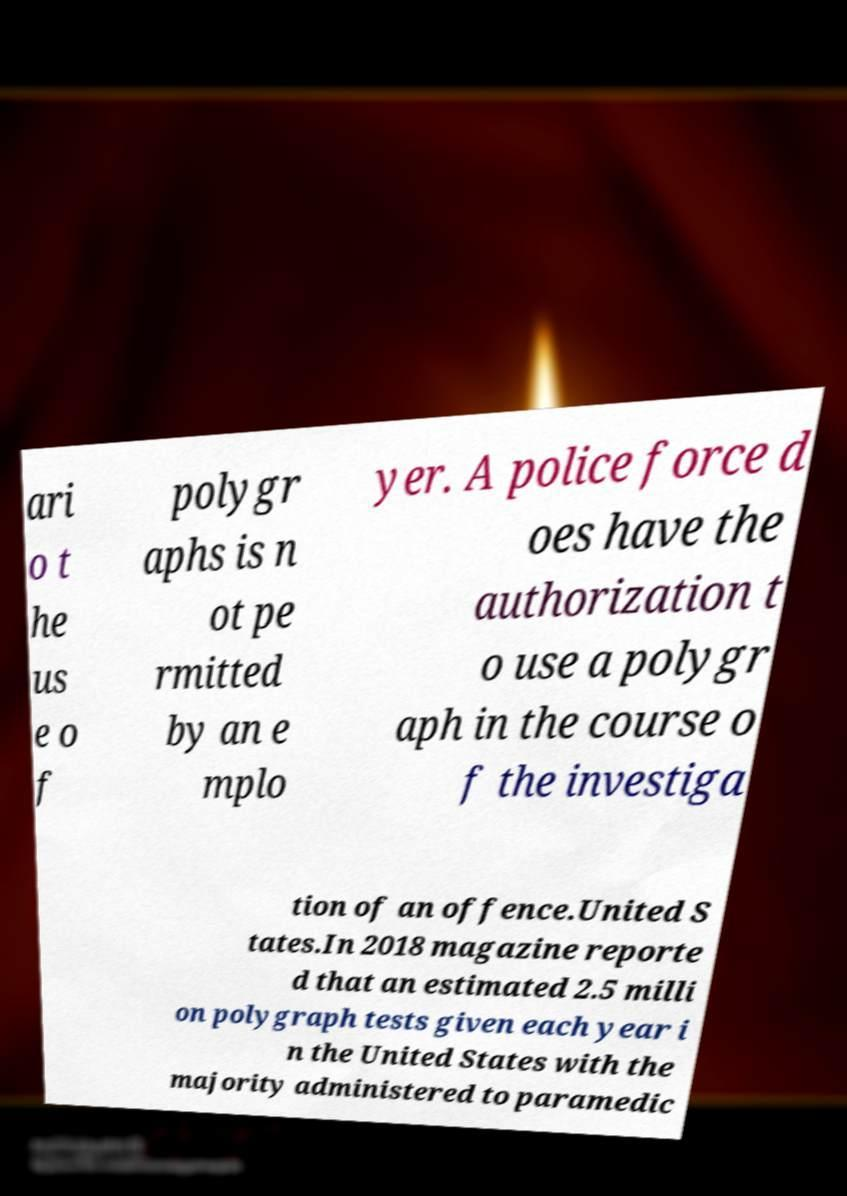Please read and relay the text visible in this image. What does it say? ari o t he us e o f polygr aphs is n ot pe rmitted by an e mplo yer. A police force d oes have the authorization t o use a polygr aph in the course o f the investiga tion of an offence.United S tates.In 2018 magazine reporte d that an estimated 2.5 milli on polygraph tests given each year i n the United States with the majority administered to paramedic 